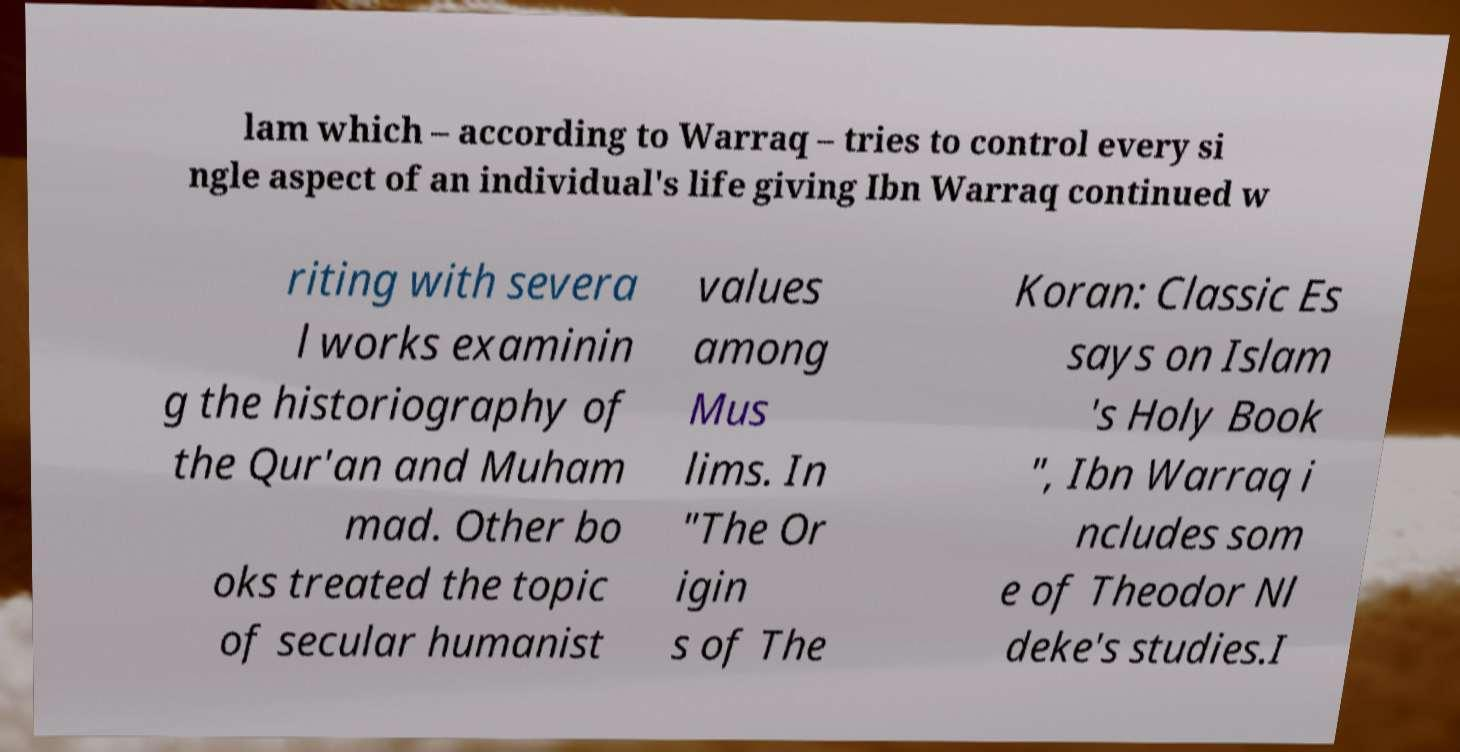Please identify and transcribe the text found in this image. lam which – according to Warraq – tries to control every si ngle aspect of an individual's life giving Ibn Warraq continued w riting with severa l works examinin g the historiography of the Qur'an and Muham mad. Other bo oks treated the topic of secular humanist values among Mus lims. In "The Or igin s of The Koran: Classic Es says on Islam 's Holy Book ", Ibn Warraq i ncludes som e of Theodor Nl deke's studies.I 